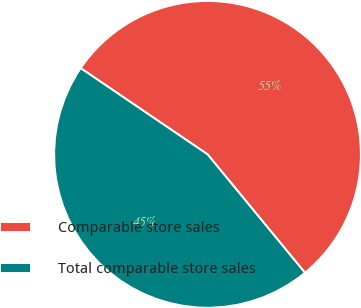<chart> <loc_0><loc_0><loc_500><loc_500><pie_chart><fcel>Comparable store sales<fcel>Total comparable store sales<nl><fcel>54.55%<fcel>45.45%<nl></chart> 